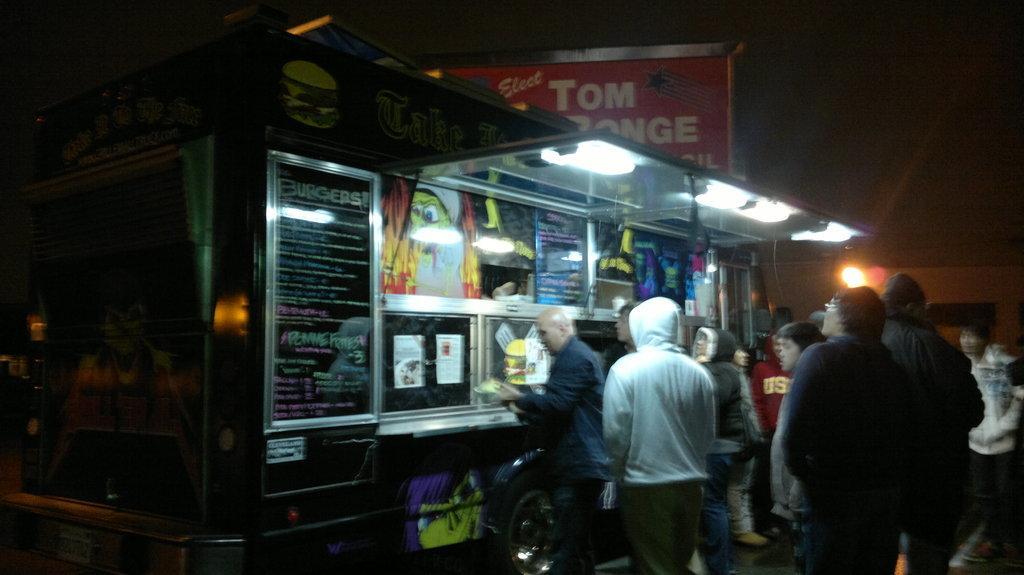In one or two sentences, can you explain what this image depicts? As we can see in the image there is a food truck, lights, posters, few people here and there, banner and sky. The image is little dark. 